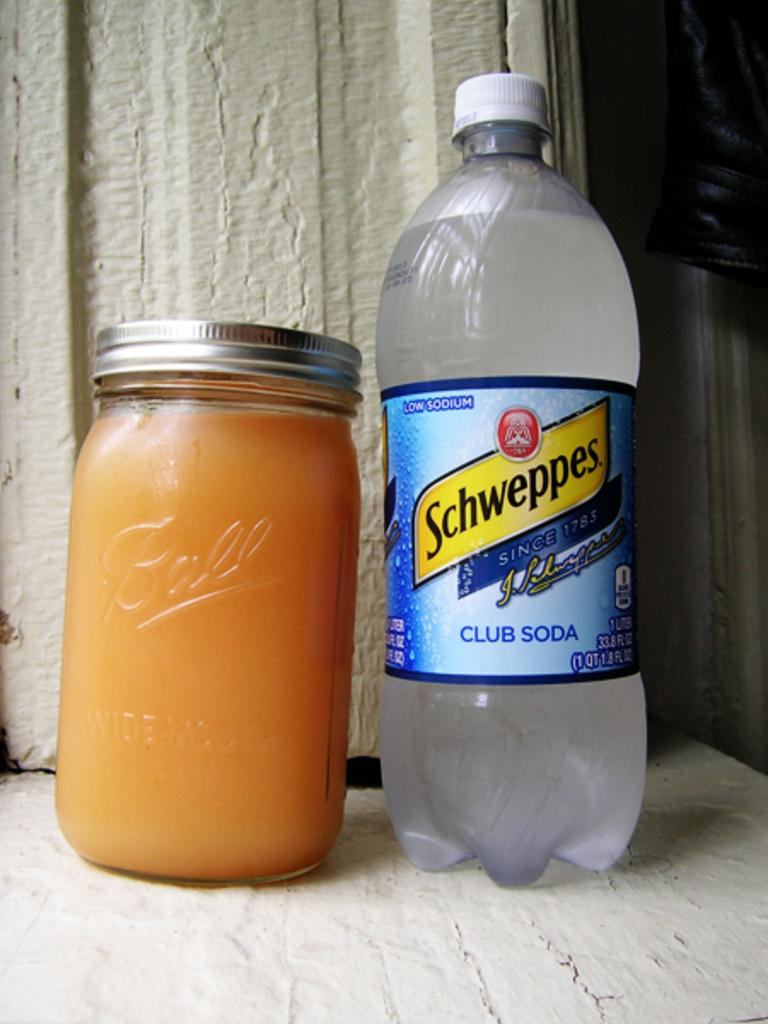<image>
Create a compact narrative representing the image presented. Certain brands of club soda have been in business and quenching thirsts since 1783. 